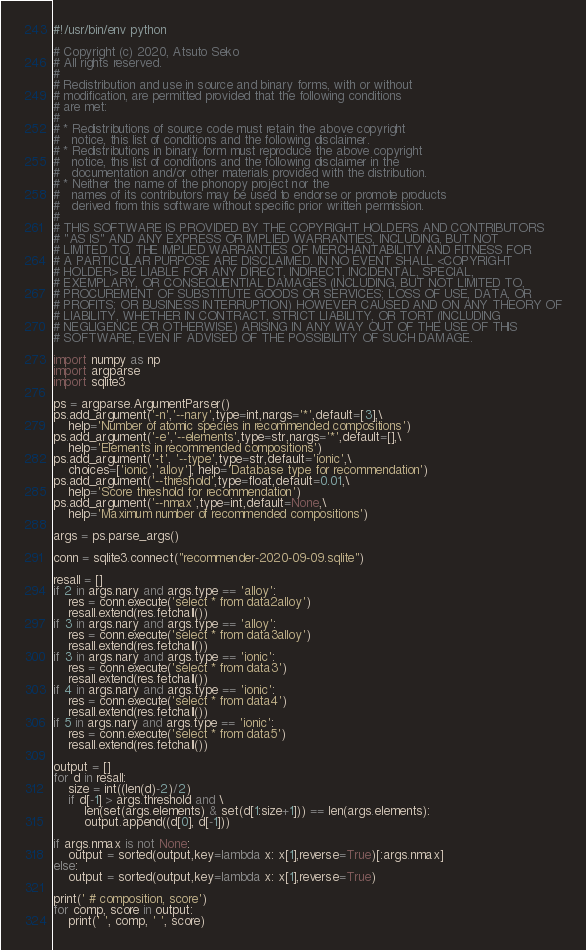<code> <loc_0><loc_0><loc_500><loc_500><_Python_>#!/usr/bin/env python

# Copyright (c) 2020, Atsuto Seko
# All rights reserved.
# 
# Redistribution and use in source and binary forms, with or without
# modification, are permitted provided that the following conditions
# are met:
# 
# * Redistributions of source code must retain the above copyright
#   notice, this list of conditions and the following disclaimer.
# * Redistributions in binary form must reproduce the above copyright
#   notice, this list of conditions and the following disclaimer in the
#   documentation and/or other materials provided with the distribution.
# * Neither the name of the phonopy project nor the
#   names of its contributors may be used to endorse or promote products
#   derived from this software without specific prior written permission.
# 
# THIS SOFTWARE IS PROVIDED BY THE COPYRIGHT HOLDERS AND CONTRIBUTORS
# "AS IS" AND ANY EXPRESS OR IMPLIED WARRANTIES, INCLUDING, BUT NOT
# LIMITED TO, THE IMPLIED WARRANTIES OF MERCHANTABILITY AND FITNESS FOR
# A PARTICULAR PURPOSE ARE DISCLAIMED. IN NO EVENT SHALL <COPYRIGHT
# HOLDER> BE LIABLE FOR ANY DIRECT, INDIRECT, INCIDENTAL, SPECIAL,
# EXEMPLARY, OR CONSEQUENTIAL DAMAGES (INCLUDING, BUT NOT LIMITED TO,
# PROCUREMENT OF SUBSTITUTE GOODS OR SERVICES; LOSS OF USE, DATA, OR
# PROFITS; OR BUSINESS INTERRUPTION) HOWEVER CAUSED AND ON ANY THEORY OF
# LIABILITY, WHETHER IN CONTRACT, STRICT LIABILITY, OR TORT (INCLUDING
# NEGLIGENCE OR OTHERWISE) ARISING IN ANY WAY OUT OF THE USE OF THIS
# SOFTWARE, EVEN IF ADVISED OF THE POSSIBILITY OF SUCH DAMAGE.

import numpy as np
import argparse
import sqlite3

ps = argparse.ArgumentParser()
ps.add_argument('-n','--nary',type=int,nargs='*',default=[3],\
    help='Number of atomic species in recommended compositions')
ps.add_argument('-e','--elements',type=str,nargs='*',default=[],\
    help='Elements in recommended compositions')
ps.add_argument('-t', '--type',type=str,default='ionic',\
    choices=['ionic','alloy'], help='Database type for recommendation')
ps.add_argument('--threshold',type=float,default=0.01,\
    help='Score threshold for recommendation')
ps.add_argument('--nmax',type=int,default=None,\
    help='Maximum number of recommended compositions')

args = ps.parse_args()

conn = sqlite3.connect("recommender-2020-09-09.sqlite")

resall = []
if 2 in args.nary and args.type == 'alloy':
    res = conn.execute('select * from data2alloy')
    resall.extend(res.fetchall())
if 3 in args.nary and args.type == 'alloy':
    res = conn.execute('select * from data3alloy')
    resall.extend(res.fetchall())
if 3 in args.nary and args.type == 'ionic':
    res = conn.execute('select * from data3')
    resall.extend(res.fetchall())
if 4 in args.nary and args.type == 'ionic':
    res = conn.execute('select * from data4')
    resall.extend(res.fetchall())
if 5 in args.nary and args.type == 'ionic':
    res = conn.execute('select * from data5')
    resall.extend(res.fetchall())

output = []
for d in resall:
    size = int((len(d)-2)/2)
    if d[-1] > args.threshold and \
        len(set(args.elements) & set(d[1:size+1])) == len(args.elements):
        output.append((d[0], d[-1]))

if args.nmax is not None:
    output = sorted(output,key=lambda x: x[1],reverse=True)[:args.nmax]
else:
    output = sorted(output,key=lambda x: x[1],reverse=True)

print(' # composition, score')
for comp, score in output:
    print(' ', comp, ' ', score)

</code> 